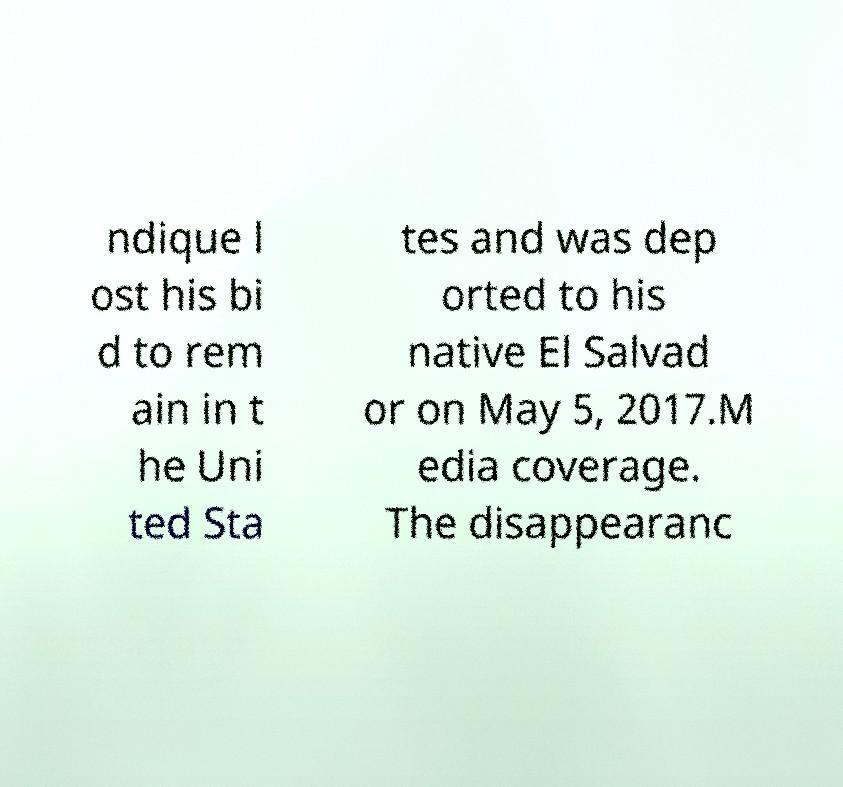Please identify and transcribe the text found in this image. ndique l ost his bi d to rem ain in t he Uni ted Sta tes and was dep orted to his native El Salvad or on May 5, 2017.M edia coverage. The disappearanc 